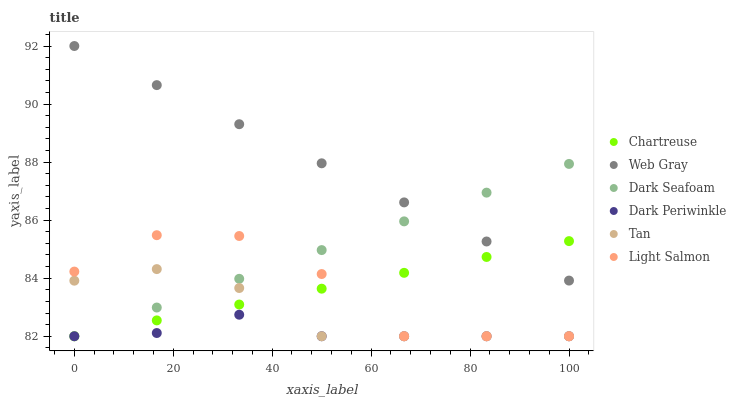Does Dark Periwinkle have the minimum area under the curve?
Answer yes or no. Yes. Does Web Gray have the maximum area under the curve?
Answer yes or no. Yes. Does Dark Seafoam have the minimum area under the curve?
Answer yes or no. No. Does Dark Seafoam have the maximum area under the curve?
Answer yes or no. No. Is Dark Seafoam the smoothest?
Answer yes or no. Yes. Is Light Salmon the roughest?
Answer yes or no. Yes. Is Web Gray the smoothest?
Answer yes or no. No. Is Web Gray the roughest?
Answer yes or no. No. Does Light Salmon have the lowest value?
Answer yes or no. Yes. Does Web Gray have the lowest value?
Answer yes or no. No. Does Web Gray have the highest value?
Answer yes or no. Yes. Does Dark Seafoam have the highest value?
Answer yes or no. No. Is Dark Periwinkle less than Web Gray?
Answer yes or no. Yes. Is Web Gray greater than Light Salmon?
Answer yes or no. Yes. Does Dark Seafoam intersect Tan?
Answer yes or no. Yes. Is Dark Seafoam less than Tan?
Answer yes or no. No. Is Dark Seafoam greater than Tan?
Answer yes or no. No. Does Dark Periwinkle intersect Web Gray?
Answer yes or no. No. 